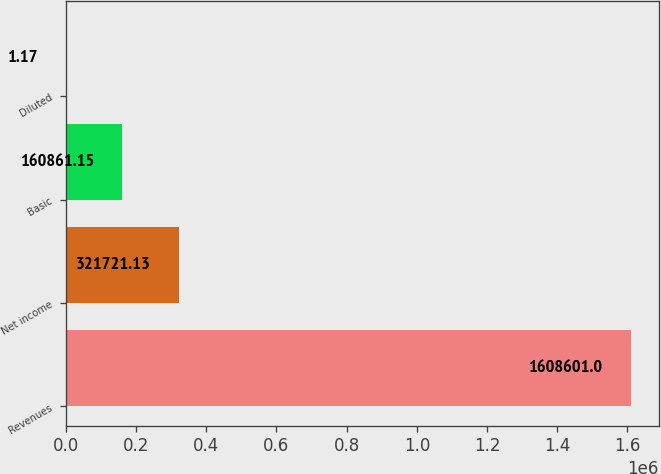Convert chart to OTSL. <chart><loc_0><loc_0><loc_500><loc_500><bar_chart><fcel>Revenues<fcel>Net income<fcel>Basic<fcel>Diluted<nl><fcel>1.6086e+06<fcel>321721<fcel>160861<fcel>1.17<nl></chart> 